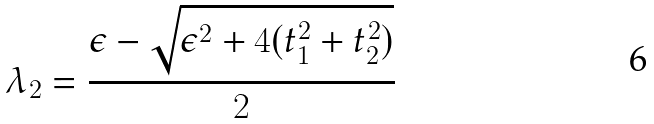<formula> <loc_0><loc_0><loc_500><loc_500>\lambda _ { 2 } = \frac { \epsilon - \sqrt { \epsilon ^ { 2 } + 4 ( t _ { 1 } ^ { 2 } + t _ { 2 } ^ { 2 } ) } } { 2 }</formula> 